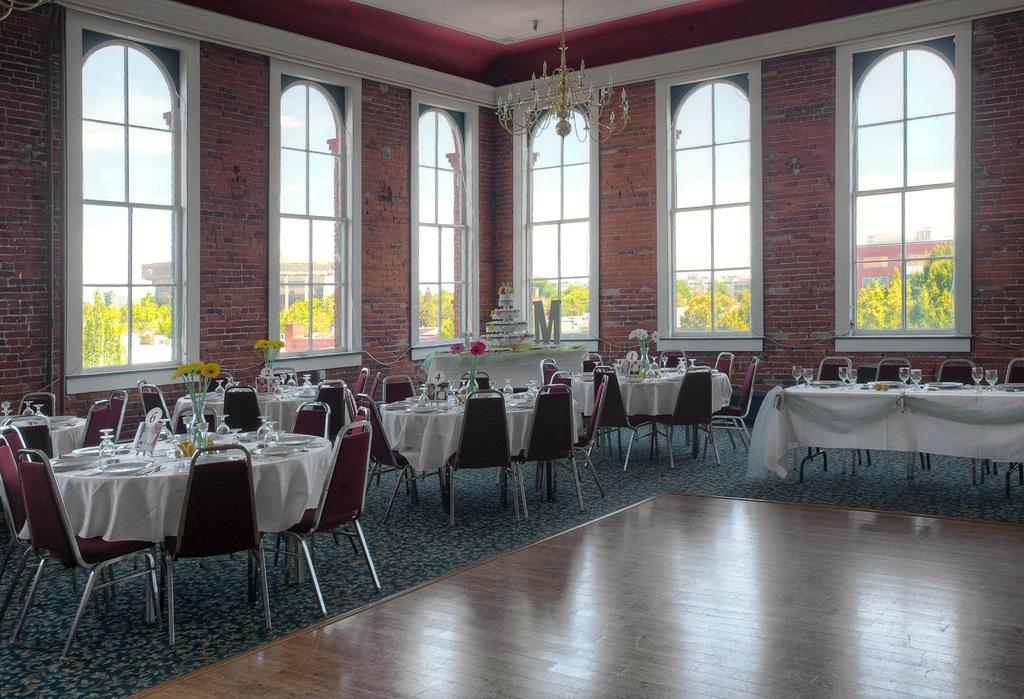What type of furniture is present in the image? There are chairs in the image. What objects are used for drinking in the image? There are glasses in the image. What objects are used for eating in the image? There are plates in the image. What type of decorative items can be seen in the image? There are flower pots in the image. What objects are present on the tables in the image? There are objects on the tables in the image. What architectural feature is present in the image? There are windows in the image. What type of vegetation is visible in the image? There are trees in the image. What part of the natural environment is visible in the image? The sky is visible in the image. What type of silk is draped over the chairs in the image? There is no silk present in the image; it only mentions chairs, glasses, plates, flower pots, objects on tables, windows, trees, and the sky. What is the shape of the square plates in the image? There are no square plates mentioned in the image; it only mentions plates, but their shape is not specified. 